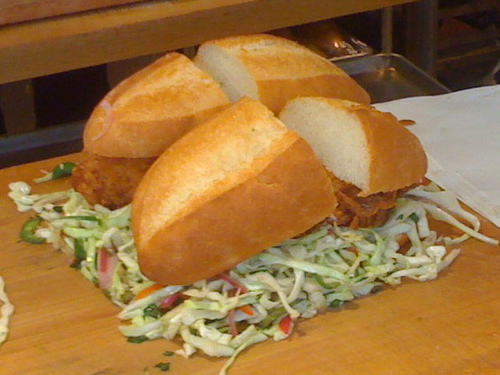What kind of occasion might this food be suitable for? This dish could be appropriate for a casual dining experience, such as a quick lunch or a meal at a food festival. It's informal and likely to be popular at gatherings with a focus on hearty, flavorful food. 